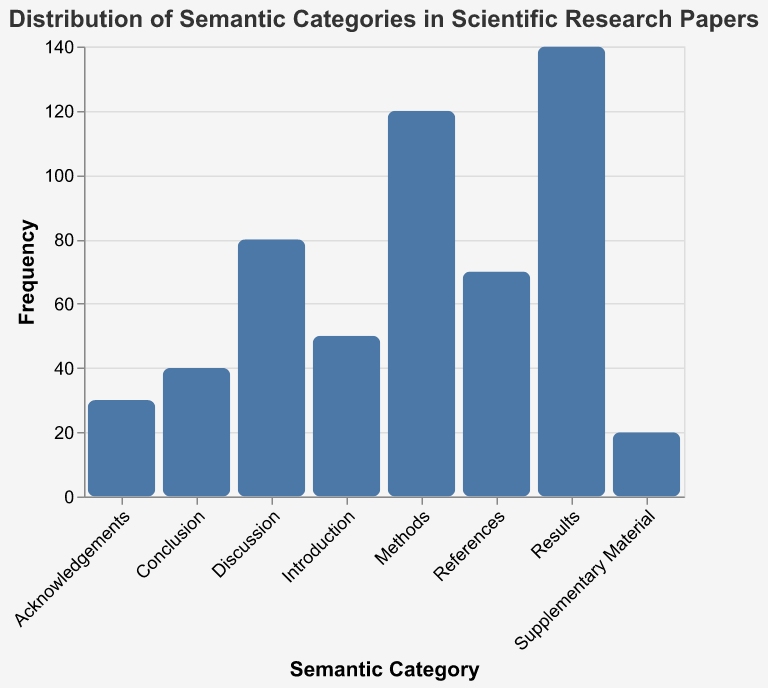What is the title of the chart? The title of the chart is located at the top of the figure and reads "Distribution of Semantic Categories in Scientific Research Papers."
Answer: Distribution of Semantic Categories in Scientific Research Papers How many categories are displayed in the chart? Count the number of distinct bars or the number of different category labels on the x-axis. There are 8 categories listed: Introduction, Methods, Results, Discussion, Conclusion, References, Acknowledgements, and Supplementary Material.
Answer: 8 Which category has the highest frequency? Identify the tallest bar on the bar chart. The "Results" category bar is the highest, indicating it has the highest count.
Answer: Results What is the frequency of the "Discussion" category? Look at the height of the "Discussion" bar on the y-axis. It reaches up to 80.
Answer: 80 How many more papers fall under "Methods" than "Introduction"? Subtract the count of "Introduction" from the count of "Methods". Methods (120) - Introduction (50) equals 70.
Answer: 70 Which categories have a frequency less than 50? Identify the bars that do not reach the 50 mark on the y-axis. These categories are Conclusion (40), Acknowledgements (30), and Supplementary Material (20).
Answer: Conclusion, Acknowledgements, Supplementary Material What is the combined frequency of the "Results" and "Methods" categories? Add the counts of "Results" and "Methods". Results (140) + Methods (120) equals 260.
Answer: 260 How does the frequency of "References" compare to "Acknowledgements"? Compare the heights of the two bars. The References bar reaches 70, and Acknowledgements reaches 30. 70 is greater than 30.
Answer: References is greater Which category has the lowest frequency? Identify the shortest bar on the chart. The "Supplementary Material" category has the lowest count of 20.
Answer: Supplementary Material 